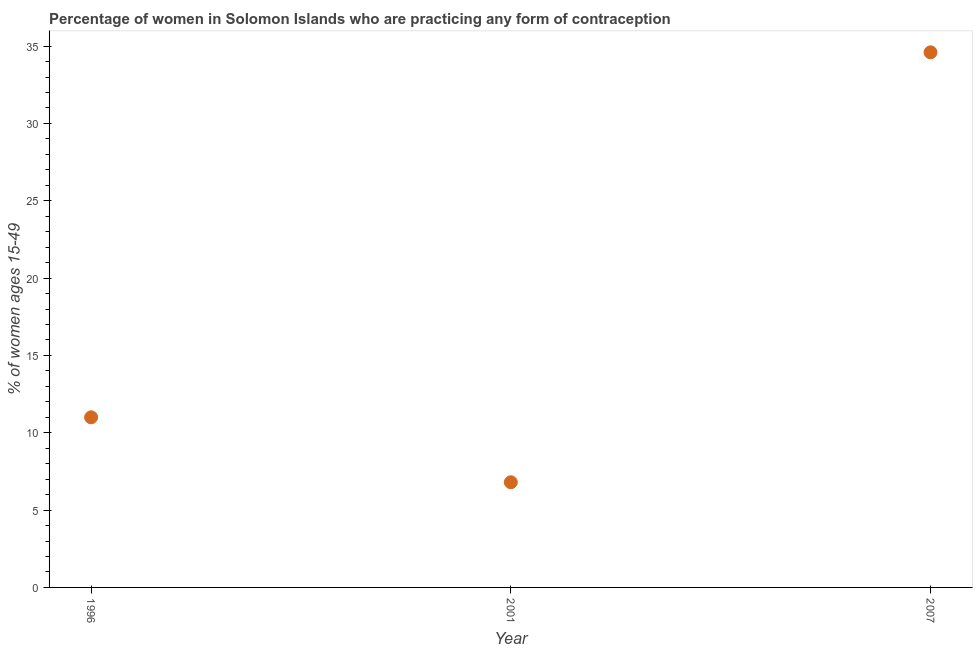Across all years, what is the maximum contraceptive prevalence?
Your answer should be very brief. 34.6. Across all years, what is the minimum contraceptive prevalence?
Offer a very short reply. 6.8. In which year was the contraceptive prevalence maximum?
Keep it short and to the point. 2007. What is the sum of the contraceptive prevalence?
Make the answer very short. 52.4. What is the difference between the contraceptive prevalence in 2001 and 2007?
Your response must be concise. -27.8. What is the average contraceptive prevalence per year?
Offer a terse response. 17.47. In how many years, is the contraceptive prevalence greater than 23 %?
Ensure brevity in your answer.  1. Do a majority of the years between 1996 and 2001 (inclusive) have contraceptive prevalence greater than 19 %?
Provide a short and direct response. No. What is the ratio of the contraceptive prevalence in 2001 to that in 2007?
Your answer should be compact. 0.2. What is the difference between the highest and the second highest contraceptive prevalence?
Your answer should be compact. 23.6. What is the difference between the highest and the lowest contraceptive prevalence?
Make the answer very short. 27.8. In how many years, is the contraceptive prevalence greater than the average contraceptive prevalence taken over all years?
Offer a very short reply. 1. How many years are there in the graph?
Make the answer very short. 3. What is the difference between two consecutive major ticks on the Y-axis?
Offer a terse response. 5. Are the values on the major ticks of Y-axis written in scientific E-notation?
Your answer should be very brief. No. Does the graph contain any zero values?
Ensure brevity in your answer.  No. What is the title of the graph?
Your answer should be compact. Percentage of women in Solomon Islands who are practicing any form of contraception. What is the label or title of the Y-axis?
Offer a very short reply. % of women ages 15-49. What is the % of women ages 15-49 in 2001?
Provide a short and direct response. 6.8. What is the % of women ages 15-49 in 2007?
Provide a succinct answer. 34.6. What is the difference between the % of women ages 15-49 in 1996 and 2001?
Your answer should be very brief. 4.2. What is the difference between the % of women ages 15-49 in 1996 and 2007?
Offer a terse response. -23.6. What is the difference between the % of women ages 15-49 in 2001 and 2007?
Make the answer very short. -27.8. What is the ratio of the % of women ages 15-49 in 1996 to that in 2001?
Keep it short and to the point. 1.62. What is the ratio of the % of women ages 15-49 in 1996 to that in 2007?
Give a very brief answer. 0.32. What is the ratio of the % of women ages 15-49 in 2001 to that in 2007?
Your answer should be compact. 0.2. 